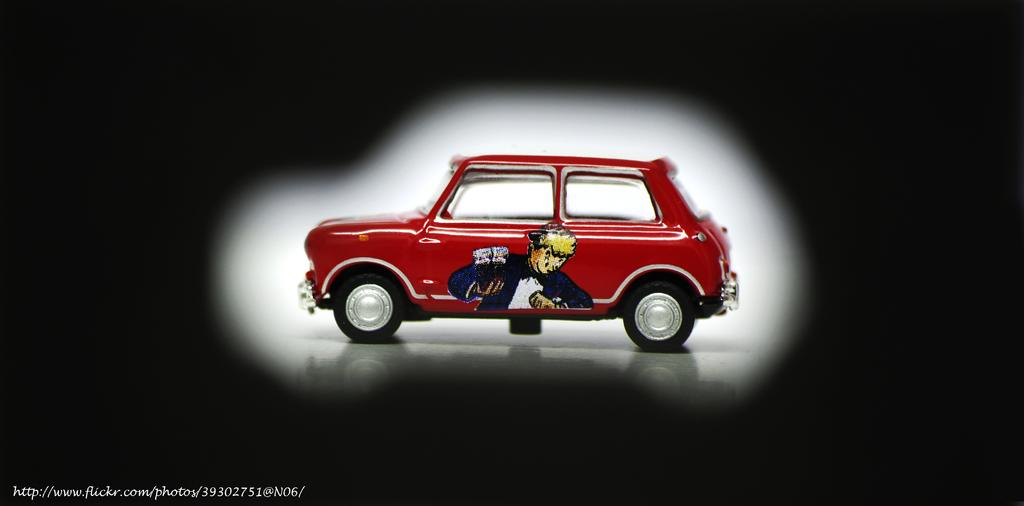What color is the car in the image? The car in the image is red. What is depicted on the car? The car has a painting of a person on it. What color is the background of the image? The background of the image is black. What is the car's tendency to thrill its passengers in the image? The image does not provide information about the car's tendency to thrill its passengers. 